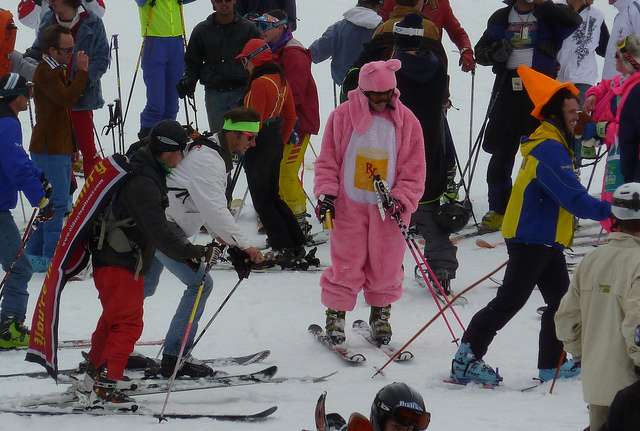Please transcribe the text in this image. RX 